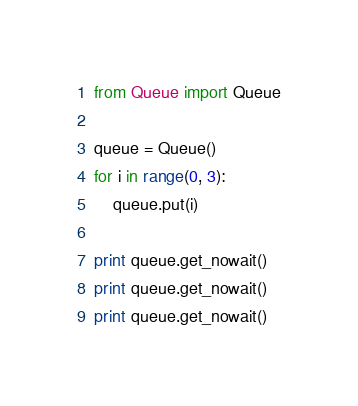<code> <loc_0><loc_0><loc_500><loc_500><_Python_>from Queue import Queue

queue = Queue()
for i in range(0, 3):
    queue.put(i)

print queue.get_nowait()
print queue.get_nowait()
print queue.get_nowait()</code> 